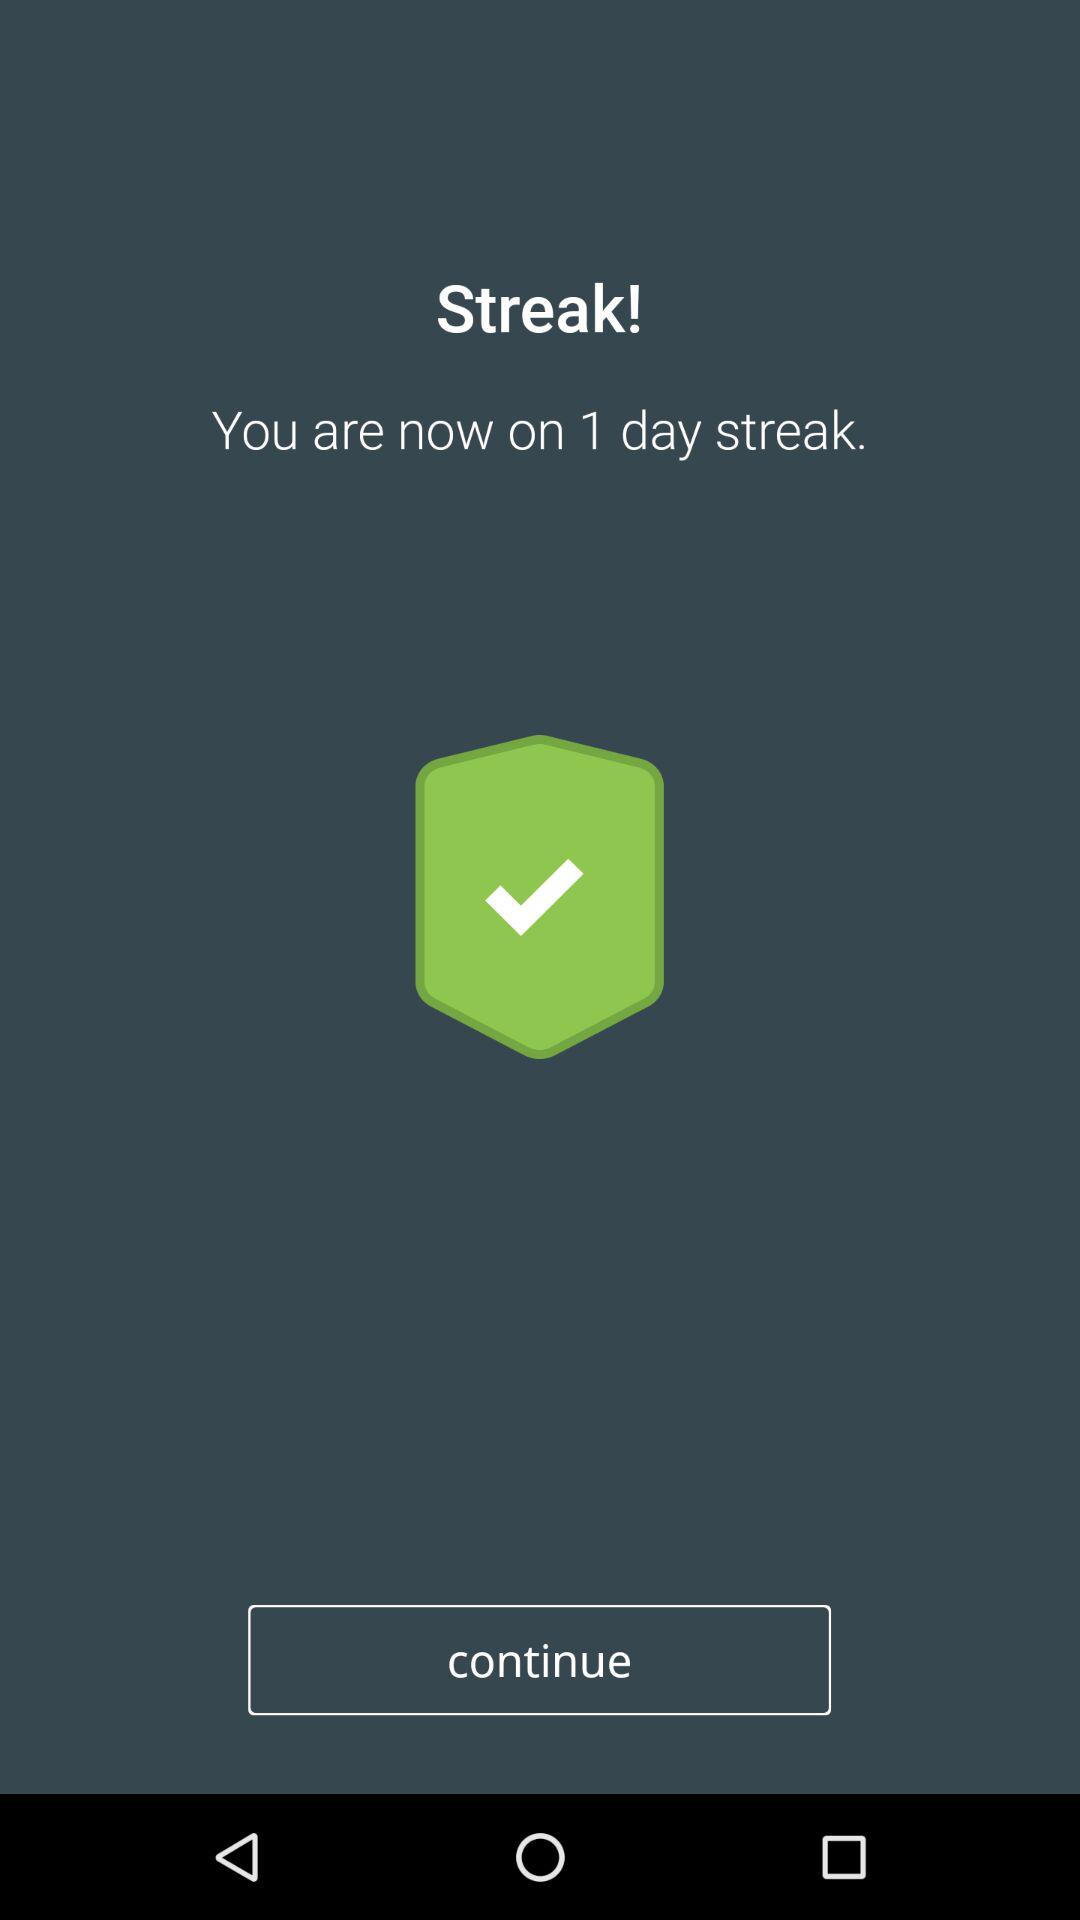How many days long is the current streak?
Answer the question using a single word or phrase. 1 